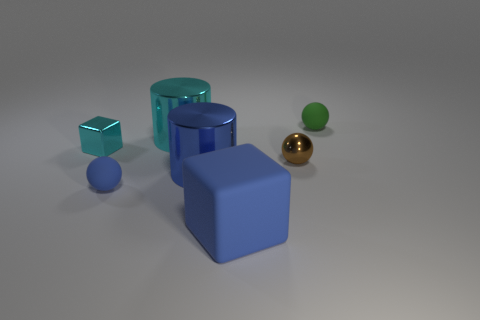What are the different colors of the objects presented in the image? The image showcases objects with a variety of colors. Starting from the left, there is a transparent cyan cube, followed by a blue cube, and a larger solid blue cylinder. Towards the right, there is a small green sphere, a gold sphere, and a cyan cylinder that appears to be semi-transparent. 